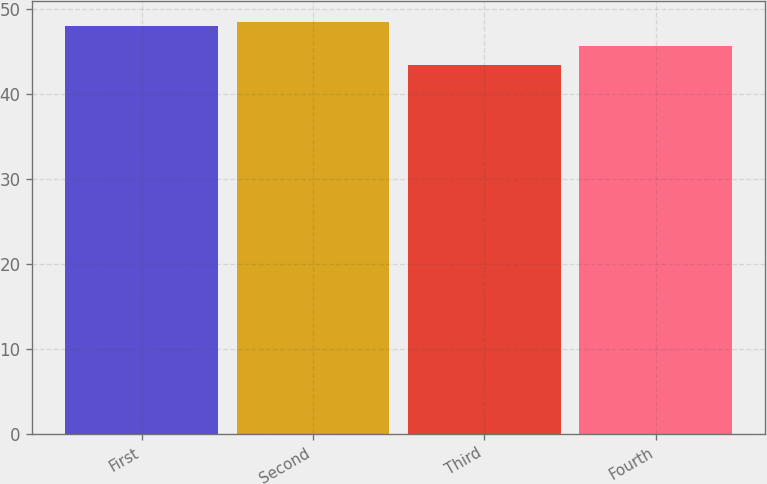Convert chart. <chart><loc_0><loc_0><loc_500><loc_500><bar_chart><fcel>First<fcel>Second<fcel>Third<fcel>Fourth<nl><fcel>48<fcel>48.48<fcel>43.38<fcel>45.68<nl></chart> 